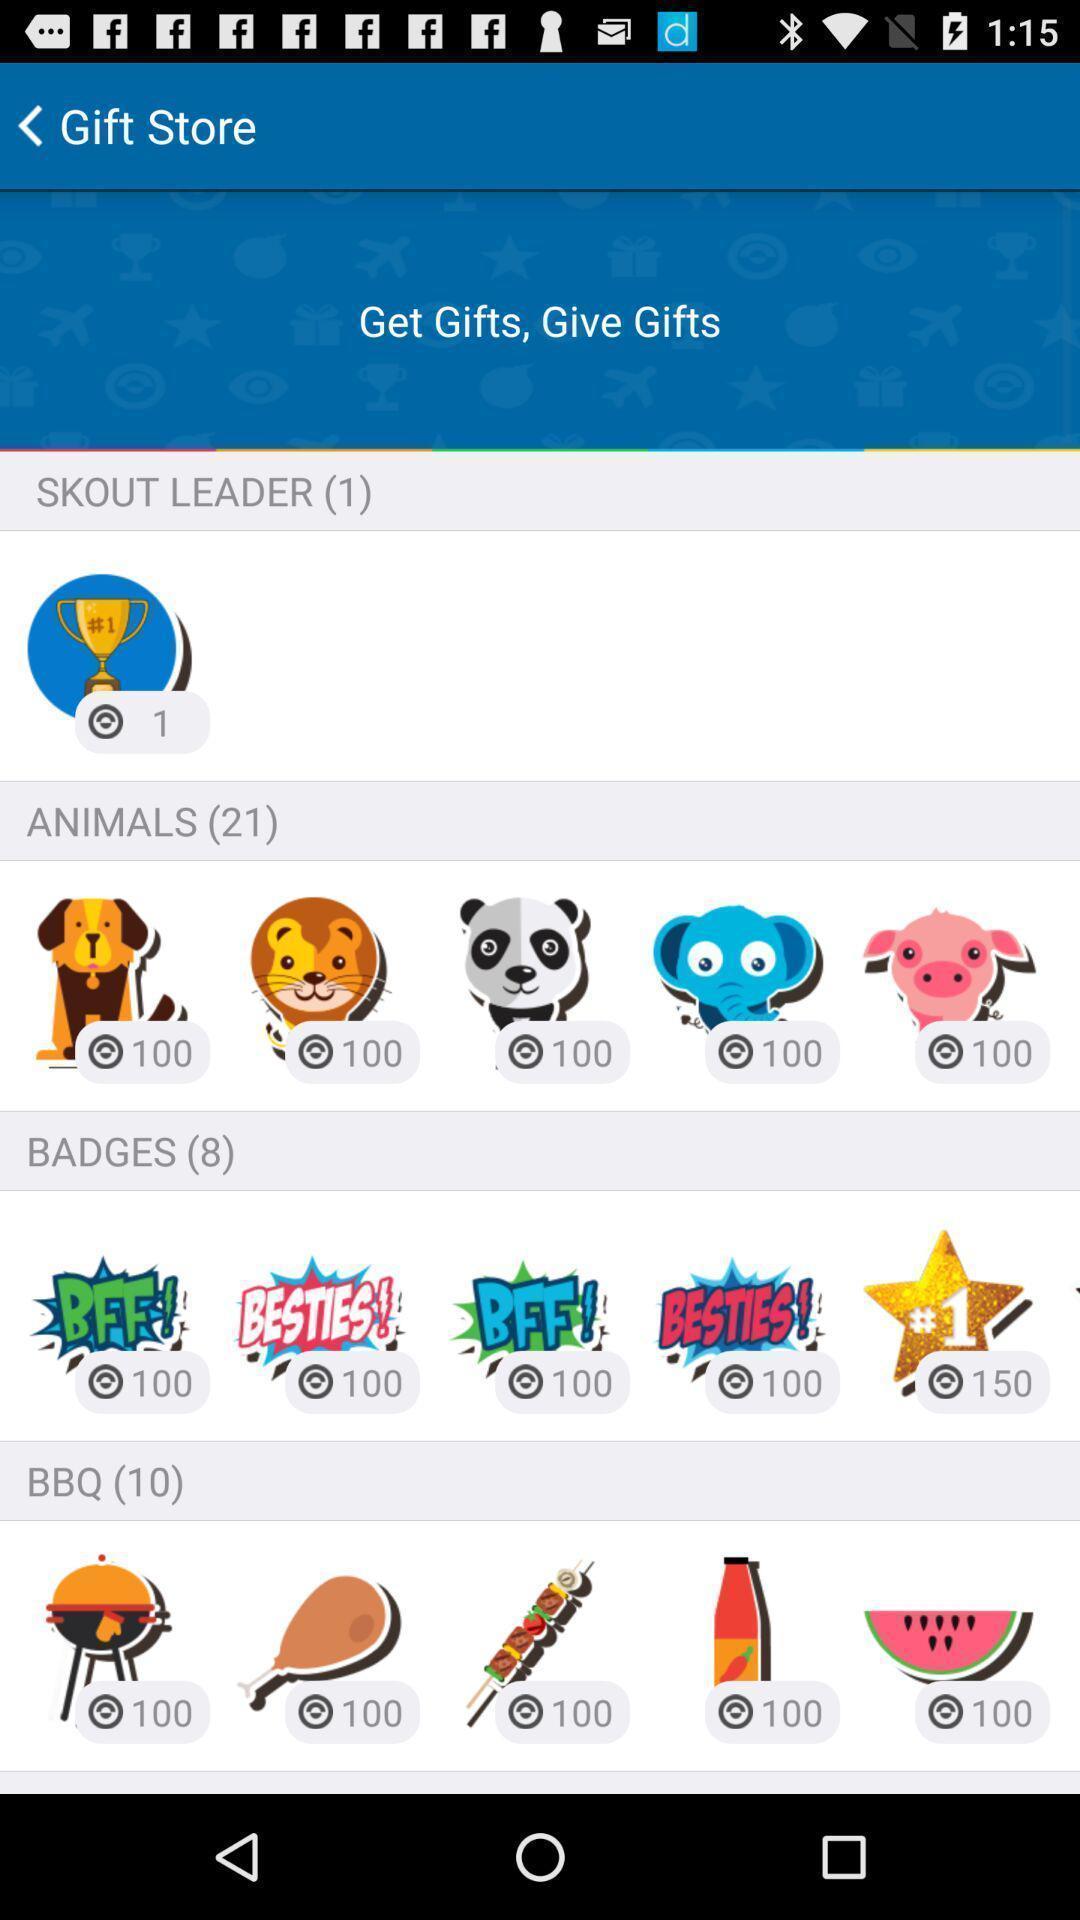Provide a description of this screenshot. Page displaying virtual gifts on social app. 